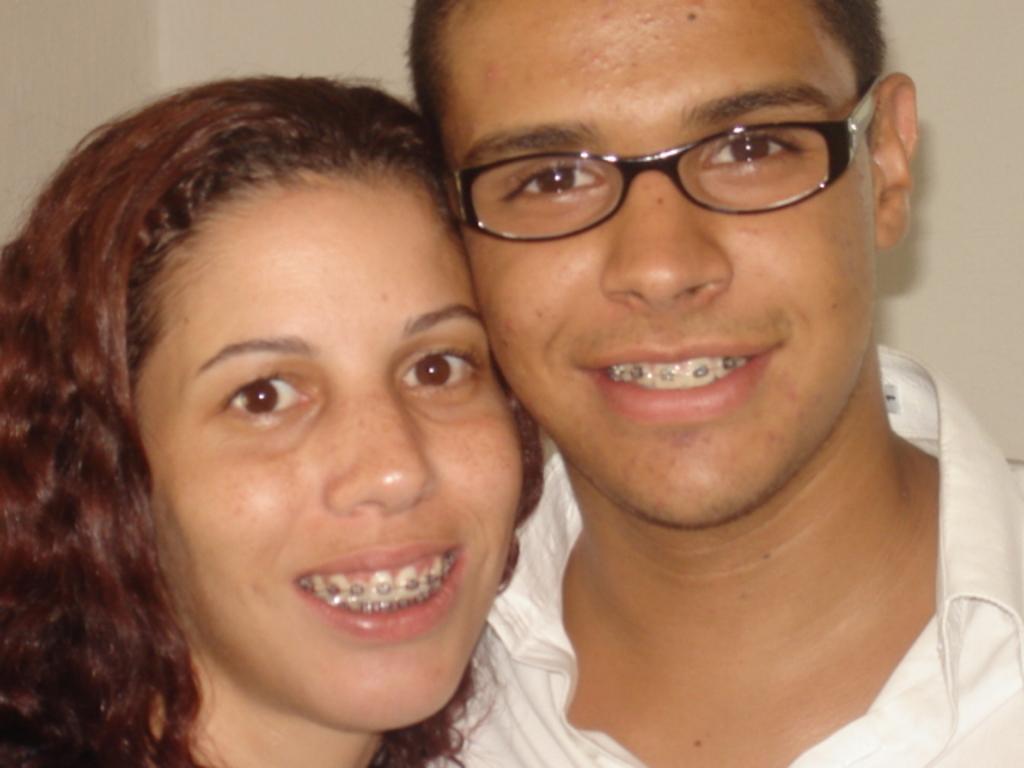In one or two sentences, can you explain what this image depicts? In this image we can see a man and a woman. The man is wearing a white color shirt. In the background, we can see the wall. 